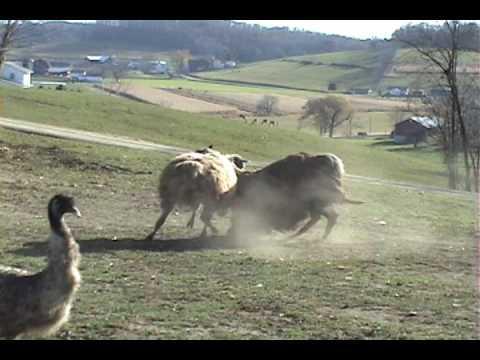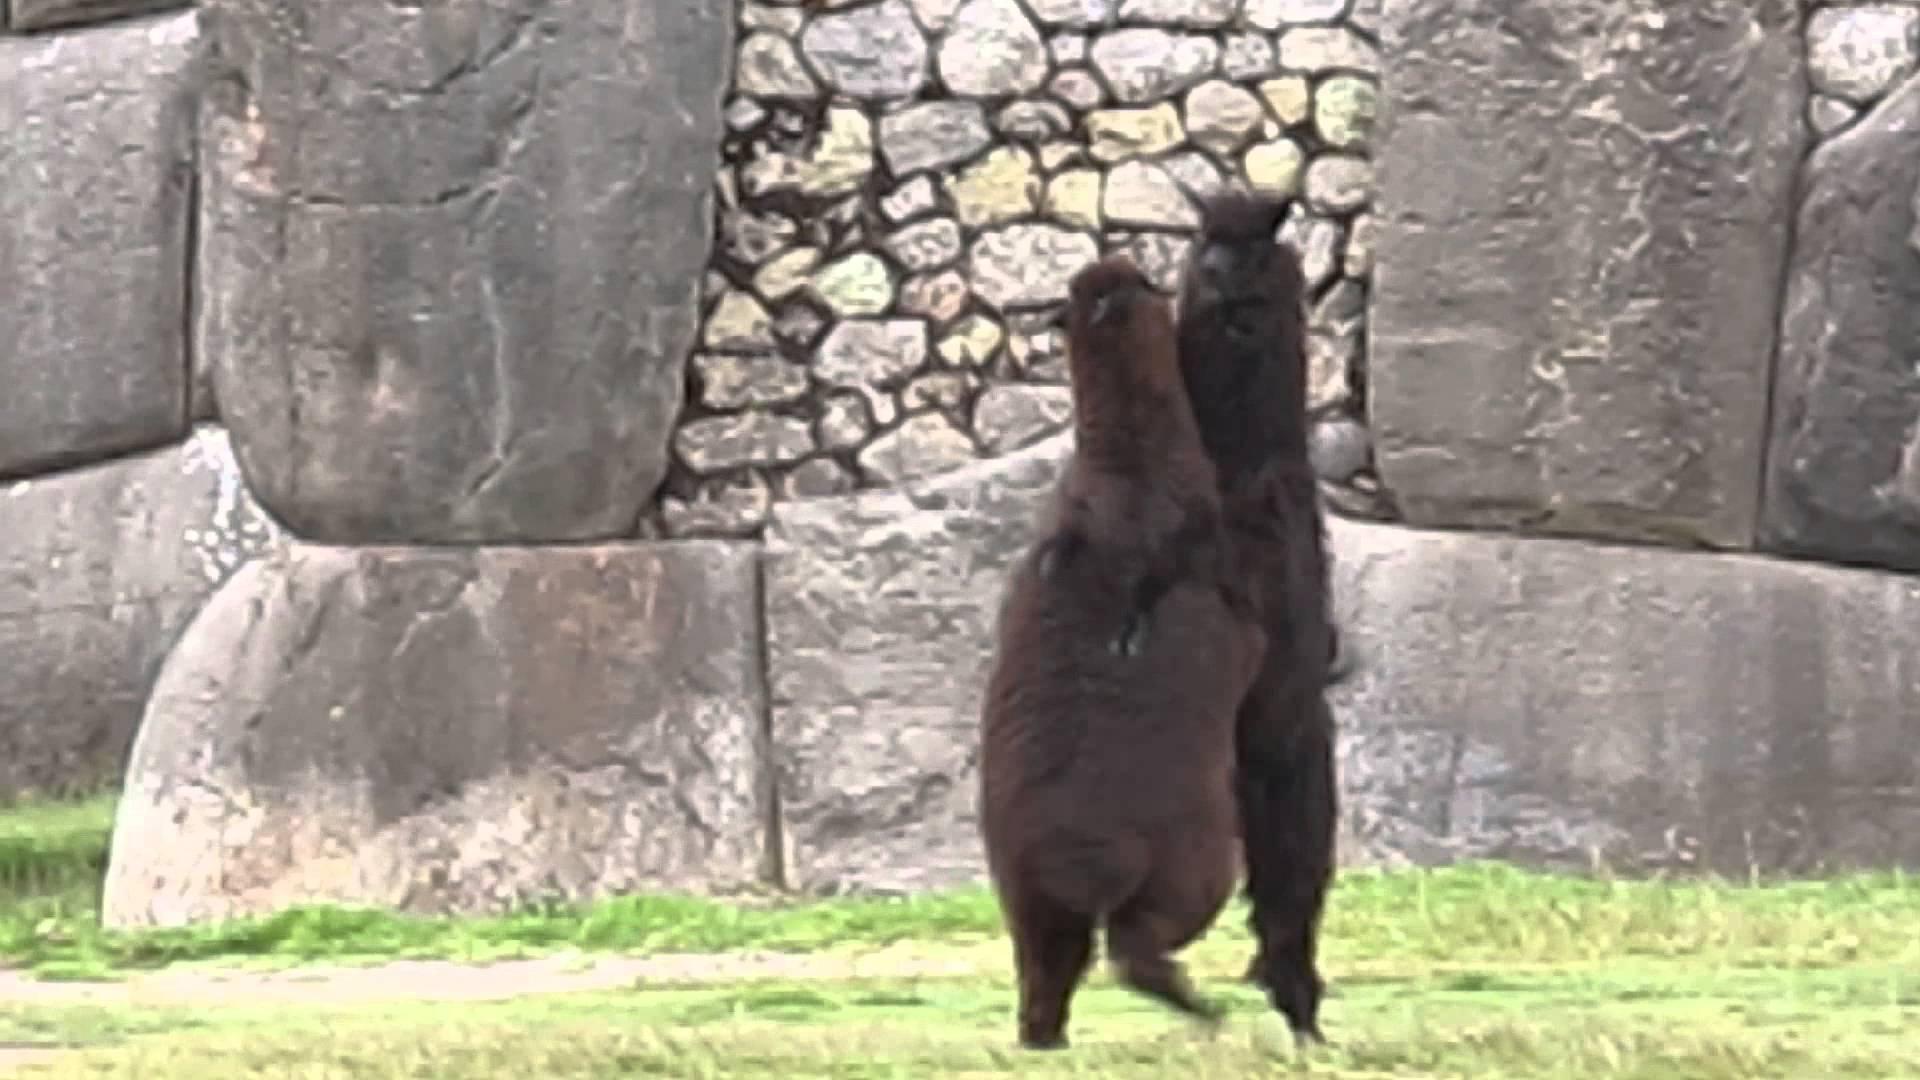The first image is the image on the left, the second image is the image on the right. Evaluate the accuracy of this statement regarding the images: "In the right image, two dark solid-colored llamas are face-to-face, with their necks stretched.". Is it true? Answer yes or no. Yes. The first image is the image on the left, the second image is the image on the right. Analyze the images presented: Is the assertion "One of the images shows two animals fighting while standing on their hind legs." valid? Answer yes or no. Yes. 